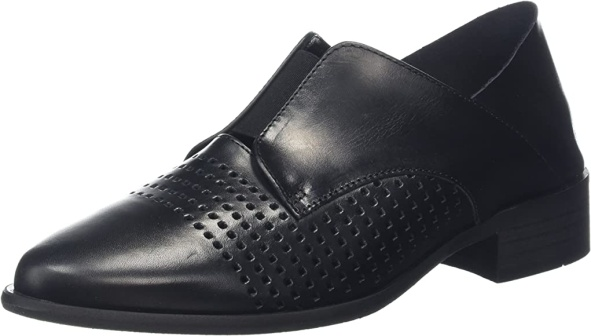What makes this shoe unique? What sets this shoe apart is its combination of classic design with unique detailing. The perforated diamond pattern on the upper front adds a distinctive touch that draws attention without overwhelming the simplicity of the design. The triangular elastic panels not only enhance the aesthetic but also provide practical functionality, ensuring a comfortable and secure fit. The low stacked heel with horizontal line details subtly elevates the elegance of the shoe. Altogether, these features harmonize to create a shoe that is both stylish and practical. Can you dive deeper into the materials used for this shoe and their benefits? This black leather shoe is crafted from high-quality materials that ensure durability and comfort. The upper is made from genuine leather, known for its breathability and ability to mold to the foot over time, providing a personalized fit. The small perforations not only contribute to the style but also enhance ventilation, making the shoe suitable for extended wear. The elastic panels are made from a strong, flexible material that retains its shape and elasticity, ensuring the shoe remains snug yet easy to slip on and off. The sole and heel of the shoe are likely constructed from a durable synthetic material that offers good traction and support, making these shoes sturdy and reliable for daily wear. Let's create a short story where this shoe plays a central role. In a bustling city, designer Mark had an important fashion show coming up—a showcase of his latest collection. Every element needed to be perfect, from the clothing to the accessories. Among his selections, a pair of black leather shoes stood out. With their delicate perforations and elegant design, they embodied the essence of his collection: modernity meeting classic style. On the night of the show, as models strutted down the runway, the shoes drew admiring glances and murmurs of approval. Beyond the aesthetics, they symbolized Mark's journey—crafted through hours of relentless effort and attention to detail. These shoes became a defining piece, earning Mark a standing ovation and rave reviews, solidifying his reputation in the fashion world. 